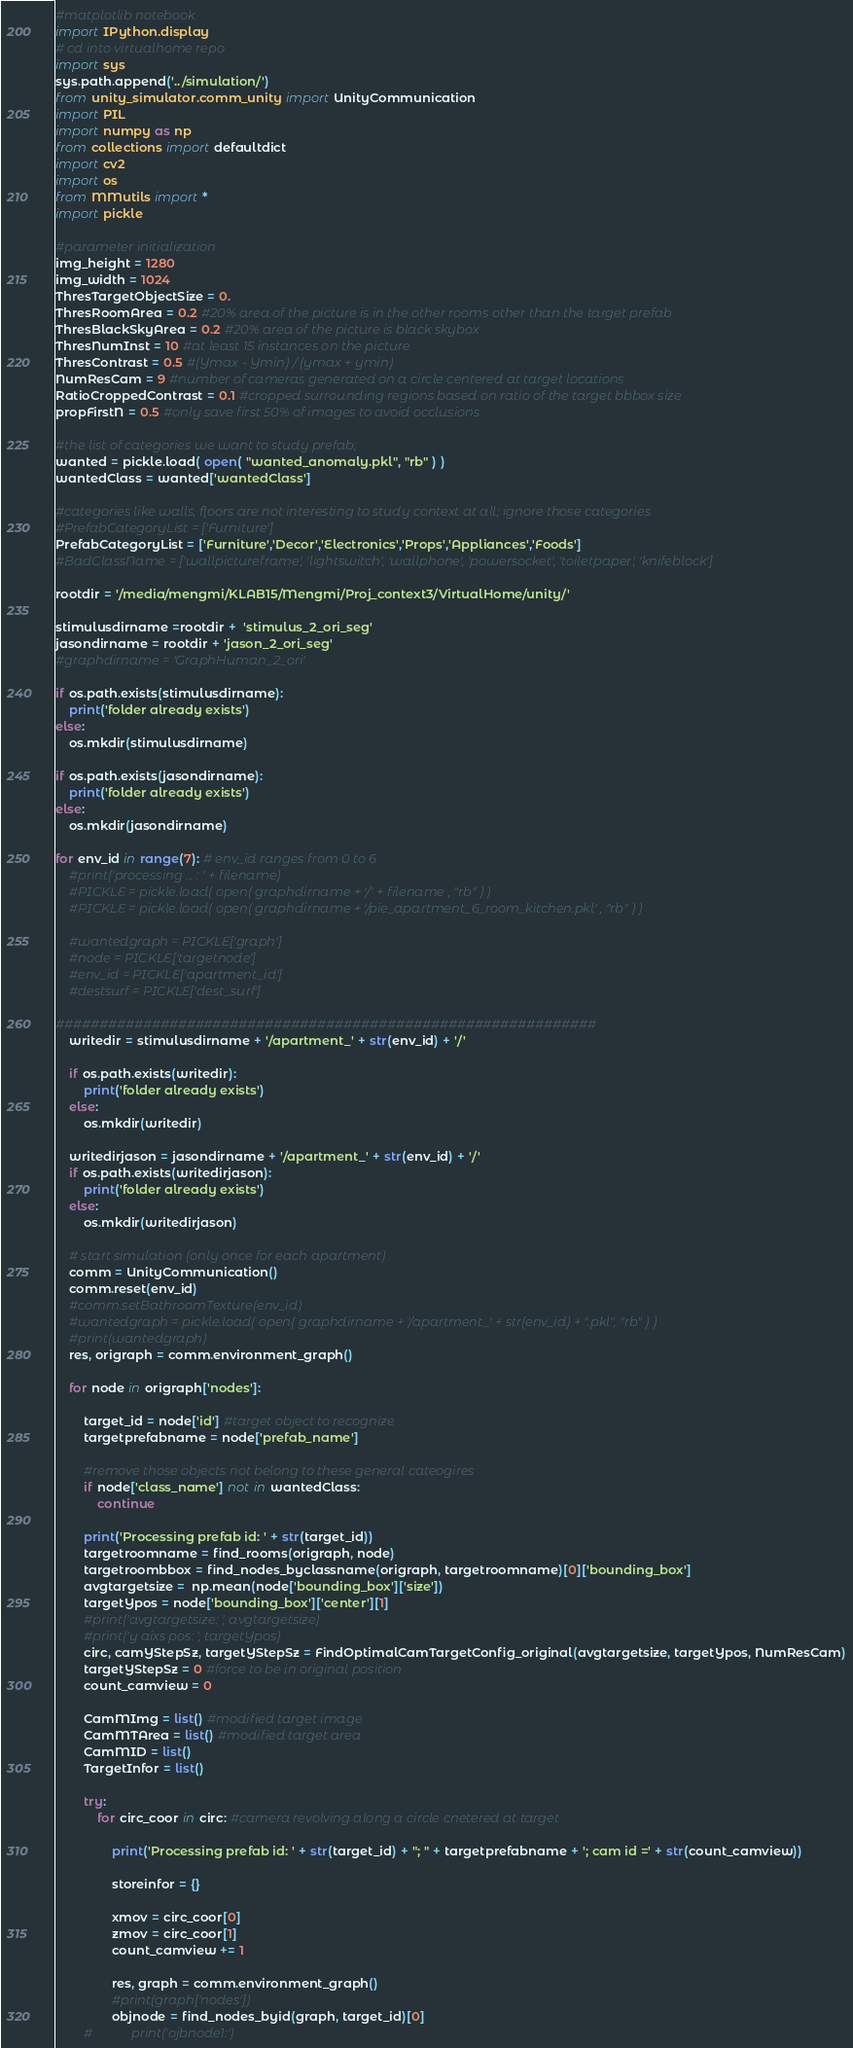<code> <loc_0><loc_0><loc_500><loc_500><_Python_>#matplotlib notebook
import IPython.display
# cd into virtualhome repo
import sys
sys.path.append('../simulation/')
from unity_simulator.comm_unity import UnityCommunication
import PIL
import numpy as np
from collections import defaultdict
import cv2
import os
from MMutils import *
import pickle

#parameter initialization
img_height = 1280
img_width = 1024
ThresTargetObjectSize = 0.
ThresRoomArea = 0.2 #20% area of the picture is in the other rooms other than the target prefab
ThresBlackSkyArea = 0.2 #20% area of the picture is black skybox
ThresNumInst = 10 #at least 15 instances on the picture
ThresContrast = 0.5 #(Ymax - Ymin) / (ymax + ymin)
NumResCam = 9 #number of cameras generated on a circle centered at target locations
RatioCroppedContrast = 0.1 #cropped surrounding regions based on ratio of the target bbbox size
propFirstN = 0.5 #only save first 50% of images to avoid occlusions

#the list of categories we want to study prefab; 
wanted = pickle.load( open( "wanted_anomaly.pkl", "rb" ) ) 
wantedClass = wanted['wantedClass']

#categories like walls, floors are not interesting to study context at all; ignore those categories
#PrefabCategoryList = ['Furniture']
PrefabCategoryList = ['Furniture','Decor','Electronics','Props','Appliances','Foods'] 
#BadClassName = ['wallpictureframe', 'lightswitch', 'wallphone', 'powersocket', 'toiletpaper', 'knifeblock']

rootdir = '/media/mengmi/KLAB15/Mengmi/Proj_context3/VirtualHome/unity/'

stimulusdirname =rootdir +  'stimulus_2_ori_seg'
jasondirname = rootdir + 'jason_2_ori_seg'
#graphdirname = 'GraphHuman_2_ori'

if os.path.exists(stimulusdirname):
    print('folder already exists')
else:
    os.mkdir(stimulusdirname)
        
if os.path.exists(jasondirname):
    print('folder already exists')
else:
    os.mkdir(jasondirname)

for env_id in range(7): # env_id ranges from 0 to 6  
    #print('processing ... : ' + filename)
    #PICKLE = pickle.load( open( graphdirname + '/' + filename , "rb" ) ) 
    #PICKLE = pickle.load( open( graphdirname + '/pie_apartment_6_room_kitchen.pkl' , "rb" ) )
    
    #wantedgraph = PICKLE['graph']
    #node = PICKLE['targetnode'] 
    #env_id = PICKLE['apartment_id']
    #destsurf = PICKLE['dest_surf']
    
##############################################################
    writedir = stimulusdirname + '/apartment_' + str(env_id) + '/'
    
    if os.path.exists(writedir):
        print('folder already exists')
    else:
        os.mkdir(writedir)
        
    writedirjason = jasondirname + '/apartment_' + str(env_id) + '/'
    if os.path.exists(writedirjason):
        print('folder already exists')
    else:
        os.mkdir(writedirjason)
    
    # start simulation (only once for each apartment)
    comm = UnityCommunication()
    comm.reset(env_id)
    #comm.setBathroomTexture(env_id)
    #wantedgraph = pickle.load( open( graphdirname + '/apartment_' + str(env_id) + ".pkl", "rb" ) ) 
    #print(wantedgraph)
    res, origraph = comm.environment_graph()
    
    for node in origraph['nodes']:
        
        target_id = node['id'] #target object to recognize 
        targetprefabname = node['prefab_name']    
        
        #remove those objects not belong to these general cateogires
        if node['class_name'] not in wantedClass:
            continue
    
        print('Processing prefab id: ' + str(target_id)) 
        targetroomname = find_rooms(origraph, node)
        targetroombbox = find_nodes_byclassname(origraph, targetroomname)[0]['bounding_box'] 
        avgtargetsize =  np.mean(node['bounding_box']['size']) 
        targetYpos = node['bounding_box']['center'][1]
        #print('avgtargetsize: ', avgtargetsize)
        #print('y aixs pos: ', targetYpos)
        circ, camYStepSz, targetYStepSz = FindOptimalCamTargetConfig_original(avgtargetsize, targetYpos, NumResCam)
        targetYStepSz = 0 #force to be in original position
        count_camview = 0
        
        CamMImg = list() #modified target image
        CamMTArea = list() #modified target area
        CamMID = list()
        TargetInfor = list()        
            
        try:
            for circ_coor in circ: #camera revolving along a circle cnetered at target
                    
                print('Processing prefab id: ' + str(target_id) + "; " + targetprefabname + '; cam id =' + str(count_camview)) 
                
                storeinfor = {}
                
                xmov = circ_coor[0]
                zmov = circ_coor[1]
                count_camview += 1
                
                res, graph = comm.environment_graph()
                #print(graph['nodes'])
                objnode = find_nodes_byid(graph, target_id)[0]
        #            print('ojbnode1:')</code> 